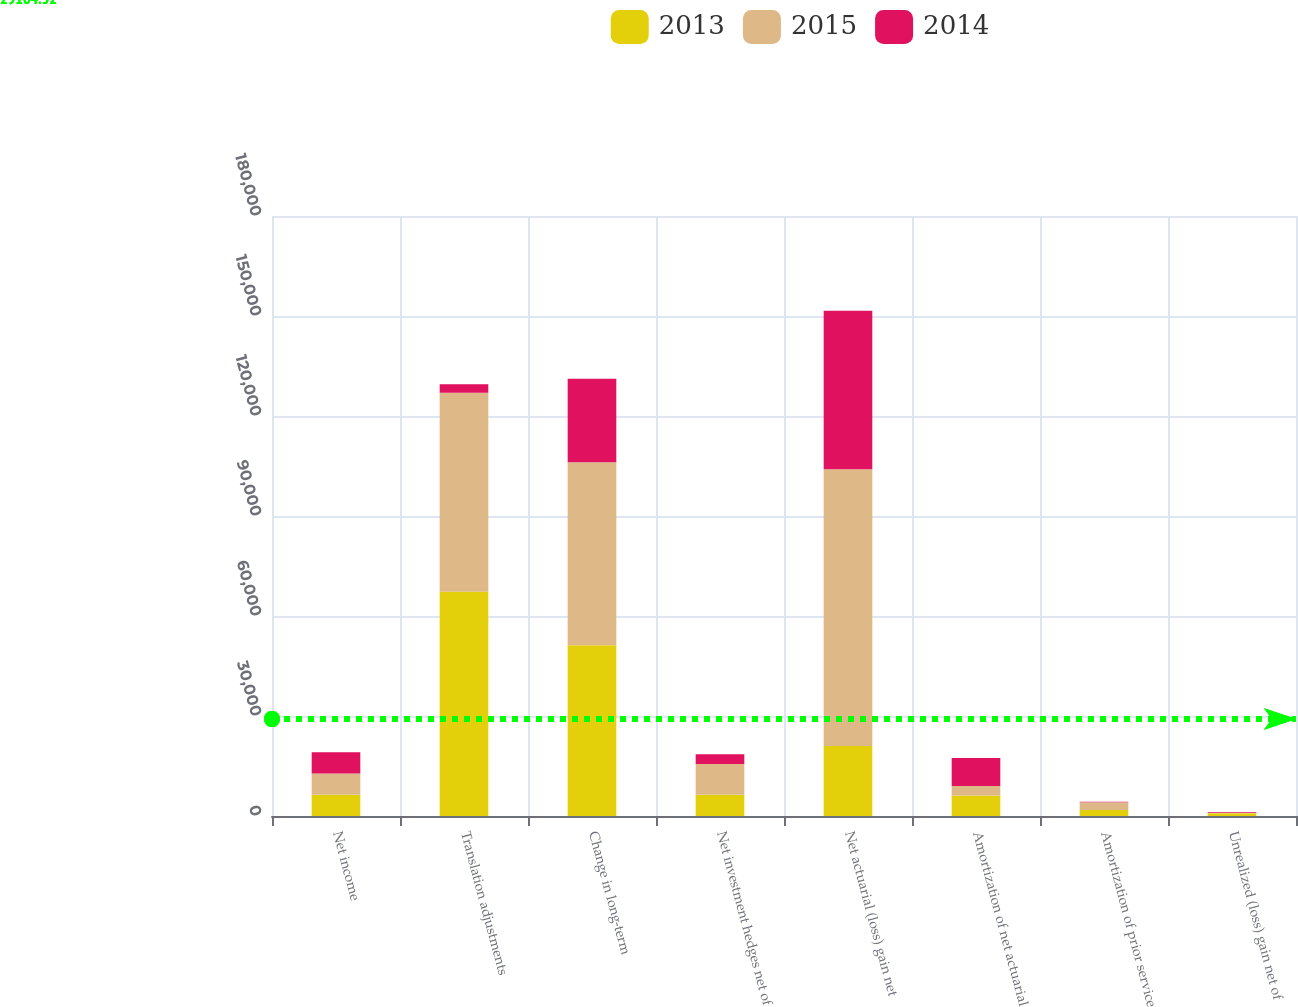Convert chart to OTSL. <chart><loc_0><loc_0><loc_500><loc_500><stacked_bar_chart><ecel><fcel>Net income<fcel>Translation adjustments<fcel>Change in long-term<fcel>Net investment hedges net of<fcel>Net actuarial (loss) gain net<fcel>Amortization of net actuarial<fcel>Amortization of prior service<fcel>Unrealized (loss) gain net of<nl><fcel>2013<fcel>6374<fcel>67245<fcel>51235<fcel>6374<fcel>21002<fcel>6137<fcel>1809<fcel>827<nl><fcel>2015<fcel>6374<fcel>59712<fcel>54906<fcel>9213<fcel>83040<fcel>2834<fcel>2292<fcel>90<nl><fcel>2014<fcel>6374<fcel>2550<fcel>25047<fcel>2938<fcel>47498<fcel>8446<fcel>174<fcel>214<nl></chart> 